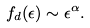Convert formula to latex. <formula><loc_0><loc_0><loc_500><loc_500>f _ { d } ( \epsilon ) \sim \epsilon ^ { \alpha } .</formula> 